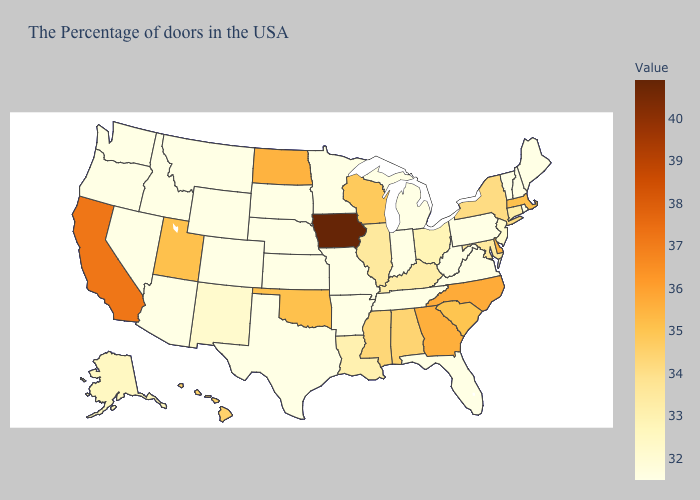Does Iowa have the highest value in the USA?
Answer briefly. Yes. Does West Virginia have a lower value than Mississippi?
Short answer required. Yes. Does the map have missing data?
Give a very brief answer. No. Which states hav the highest value in the Northeast?
Give a very brief answer. Massachusetts. Does Washington have the highest value in the USA?
Short answer required. No. Among the states that border Florida , does Georgia have the highest value?
Concise answer only. Yes. Among the states that border Georgia , which have the highest value?
Write a very short answer. North Carolina. Does Iowa have the highest value in the USA?
Keep it brief. Yes. 